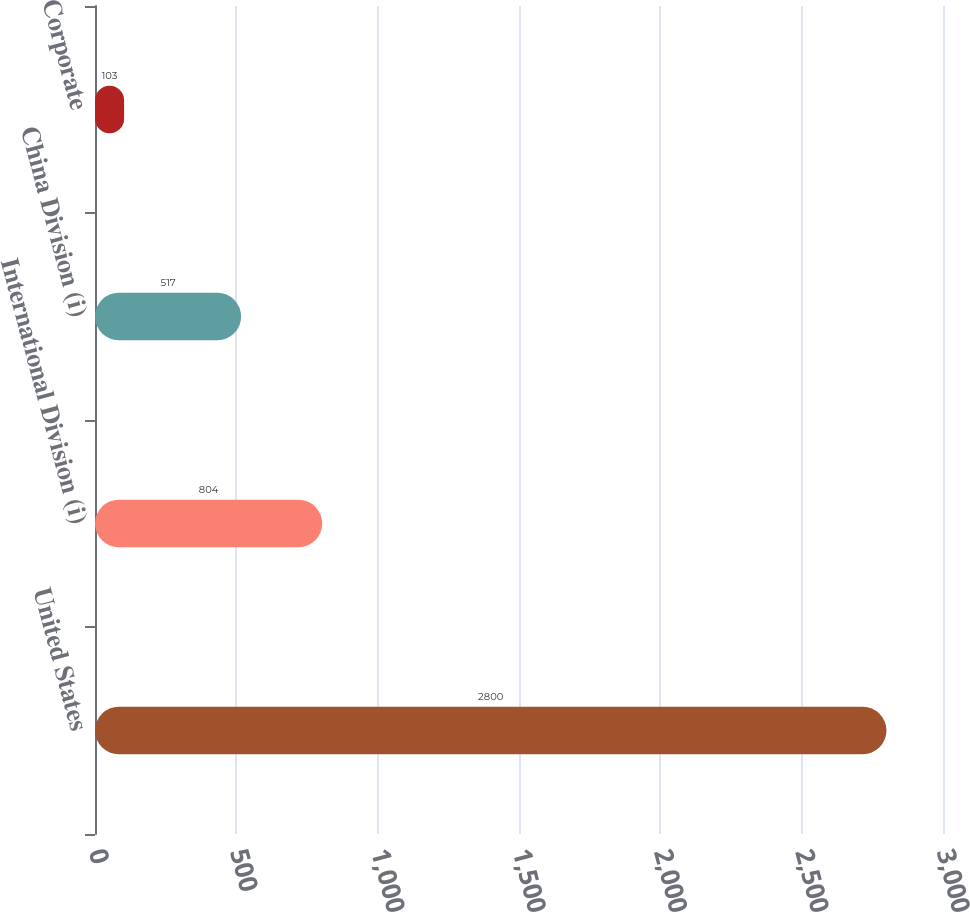<chart> <loc_0><loc_0><loc_500><loc_500><bar_chart><fcel>United States<fcel>International Division (i)<fcel>China Division (i)<fcel>Corporate<nl><fcel>2800<fcel>804<fcel>517<fcel>103<nl></chart> 